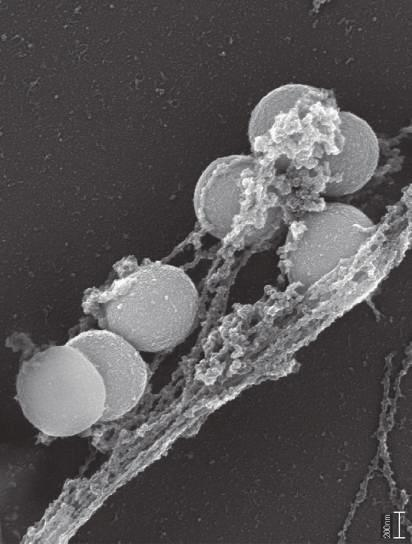two have lost whose nuclei?
Answer the question using a single word or phrase. Their 